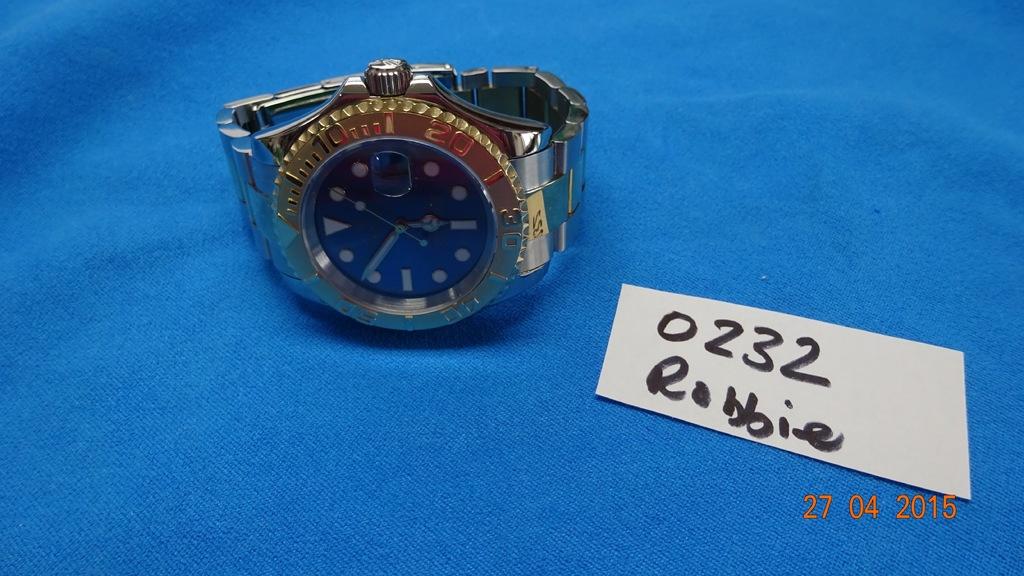What time does the watch show?
Your answer should be compact. 5:51. 